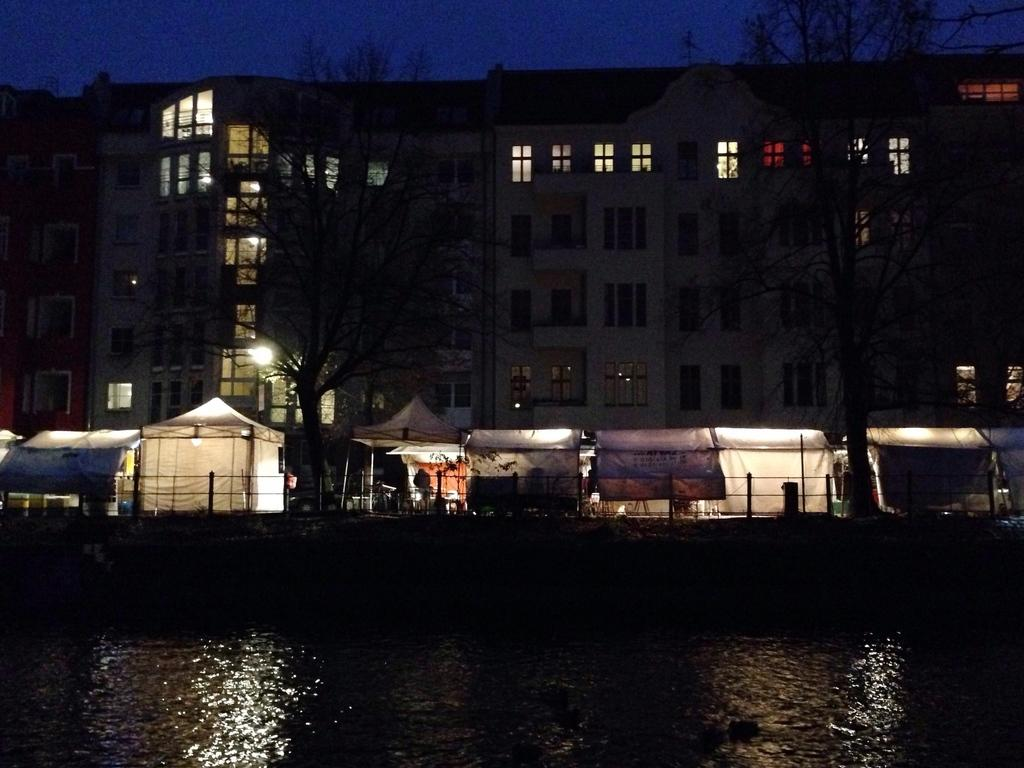What type of structure is present in the image? There is a building in the image. What can be seen in the middle of the image? There are boats in the middle of the image. What is visible at the bottom of the image? Water is visible at the bottom of the image. What is visible at the top of the image? The sky is visible at the top of the image. Can you tell me how many fangs are visible on the building in the image? There are no fangs present on the building in the image. What type of competition is taking place in the image? There is no competition depicted in the image; it features a building, boats, water, and the sky. 